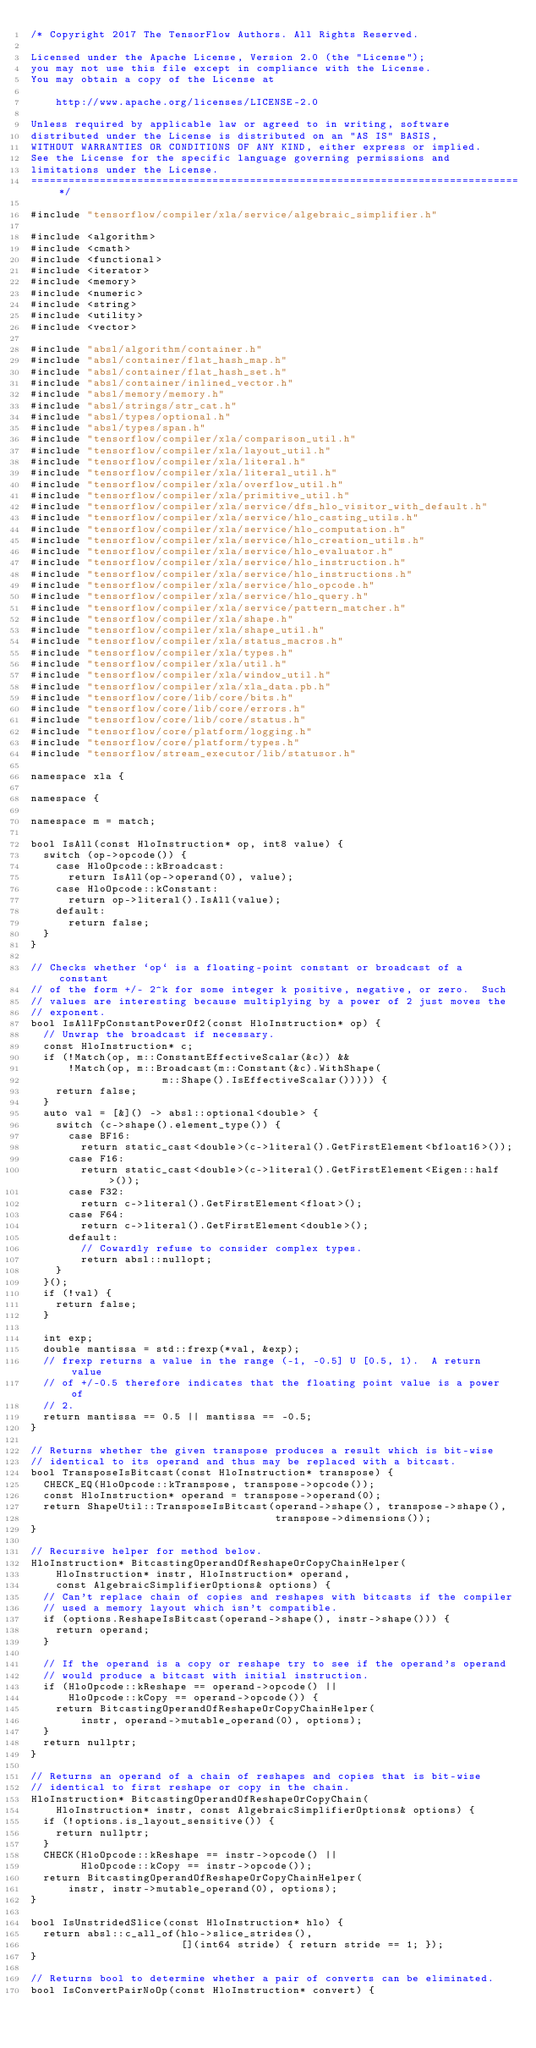Convert code to text. <code><loc_0><loc_0><loc_500><loc_500><_C++_>/* Copyright 2017 The TensorFlow Authors. All Rights Reserved.

Licensed under the Apache License, Version 2.0 (the "License");
you may not use this file except in compliance with the License.
You may obtain a copy of the License at

    http://www.apache.org/licenses/LICENSE-2.0

Unless required by applicable law or agreed to in writing, software
distributed under the License is distributed on an "AS IS" BASIS,
WITHOUT WARRANTIES OR CONDITIONS OF ANY KIND, either express or implied.
See the License for the specific language governing permissions and
limitations under the License.
==============================================================================*/

#include "tensorflow/compiler/xla/service/algebraic_simplifier.h"

#include <algorithm>
#include <cmath>
#include <functional>
#include <iterator>
#include <memory>
#include <numeric>
#include <string>
#include <utility>
#include <vector>

#include "absl/algorithm/container.h"
#include "absl/container/flat_hash_map.h"
#include "absl/container/flat_hash_set.h"
#include "absl/container/inlined_vector.h"
#include "absl/memory/memory.h"
#include "absl/strings/str_cat.h"
#include "absl/types/optional.h"
#include "absl/types/span.h"
#include "tensorflow/compiler/xla/comparison_util.h"
#include "tensorflow/compiler/xla/layout_util.h"
#include "tensorflow/compiler/xla/literal.h"
#include "tensorflow/compiler/xla/literal_util.h"
#include "tensorflow/compiler/xla/overflow_util.h"
#include "tensorflow/compiler/xla/primitive_util.h"
#include "tensorflow/compiler/xla/service/dfs_hlo_visitor_with_default.h"
#include "tensorflow/compiler/xla/service/hlo_casting_utils.h"
#include "tensorflow/compiler/xla/service/hlo_computation.h"
#include "tensorflow/compiler/xla/service/hlo_creation_utils.h"
#include "tensorflow/compiler/xla/service/hlo_evaluator.h"
#include "tensorflow/compiler/xla/service/hlo_instruction.h"
#include "tensorflow/compiler/xla/service/hlo_instructions.h"
#include "tensorflow/compiler/xla/service/hlo_opcode.h"
#include "tensorflow/compiler/xla/service/hlo_query.h"
#include "tensorflow/compiler/xla/service/pattern_matcher.h"
#include "tensorflow/compiler/xla/shape.h"
#include "tensorflow/compiler/xla/shape_util.h"
#include "tensorflow/compiler/xla/status_macros.h"
#include "tensorflow/compiler/xla/types.h"
#include "tensorflow/compiler/xla/util.h"
#include "tensorflow/compiler/xla/window_util.h"
#include "tensorflow/compiler/xla/xla_data.pb.h"
#include "tensorflow/core/lib/core/bits.h"
#include "tensorflow/core/lib/core/errors.h"
#include "tensorflow/core/lib/core/status.h"
#include "tensorflow/core/platform/logging.h"
#include "tensorflow/core/platform/types.h"
#include "tensorflow/stream_executor/lib/statusor.h"

namespace xla {

namespace {

namespace m = match;

bool IsAll(const HloInstruction* op, int8 value) {
  switch (op->opcode()) {
    case HloOpcode::kBroadcast:
      return IsAll(op->operand(0), value);
    case HloOpcode::kConstant:
      return op->literal().IsAll(value);
    default:
      return false;
  }
}

// Checks whether `op` is a floating-point constant or broadcast of a constant
// of the form +/- 2^k for some integer k positive, negative, or zero.  Such
// values are interesting because multiplying by a power of 2 just moves the
// exponent.
bool IsAllFpConstantPowerOf2(const HloInstruction* op) {
  // Unwrap the broadcast if necessary.
  const HloInstruction* c;
  if (!Match(op, m::ConstantEffectiveScalar(&c)) &&
      !Match(op, m::Broadcast(m::Constant(&c).WithShape(
                     m::Shape().IsEffectiveScalar())))) {
    return false;
  }
  auto val = [&]() -> absl::optional<double> {
    switch (c->shape().element_type()) {
      case BF16:
        return static_cast<double>(c->literal().GetFirstElement<bfloat16>());
      case F16:
        return static_cast<double>(c->literal().GetFirstElement<Eigen::half>());
      case F32:
        return c->literal().GetFirstElement<float>();
      case F64:
        return c->literal().GetFirstElement<double>();
      default:
        // Cowardly refuse to consider complex types.
        return absl::nullopt;
    }
  }();
  if (!val) {
    return false;
  }

  int exp;
  double mantissa = std::frexp(*val, &exp);
  // frexp returns a value in the range (-1, -0.5] U [0.5, 1).  A return value
  // of +/-0.5 therefore indicates that the floating point value is a power of
  // 2.
  return mantissa == 0.5 || mantissa == -0.5;
}

// Returns whether the given transpose produces a result which is bit-wise
// identical to its operand and thus may be replaced with a bitcast.
bool TransposeIsBitcast(const HloInstruction* transpose) {
  CHECK_EQ(HloOpcode::kTranspose, transpose->opcode());
  const HloInstruction* operand = transpose->operand(0);
  return ShapeUtil::TransposeIsBitcast(operand->shape(), transpose->shape(),
                                       transpose->dimensions());
}

// Recursive helper for method below.
HloInstruction* BitcastingOperandOfReshapeOrCopyChainHelper(
    HloInstruction* instr, HloInstruction* operand,
    const AlgebraicSimplifierOptions& options) {
  // Can't replace chain of copies and reshapes with bitcasts if the compiler
  // used a memory layout which isn't compatible.
  if (options.ReshapeIsBitcast(operand->shape(), instr->shape())) {
    return operand;
  }

  // If the operand is a copy or reshape try to see if the operand's operand
  // would produce a bitcast with initial instruction.
  if (HloOpcode::kReshape == operand->opcode() ||
      HloOpcode::kCopy == operand->opcode()) {
    return BitcastingOperandOfReshapeOrCopyChainHelper(
        instr, operand->mutable_operand(0), options);
  }
  return nullptr;
}

// Returns an operand of a chain of reshapes and copies that is bit-wise
// identical to first reshape or copy in the chain.
HloInstruction* BitcastingOperandOfReshapeOrCopyChain(
    HloInstruction* instr, const AlgebraicSimplifierOptions& options) {
  if (!options.is_layout_sensitive()) {
    return nullptr;
  }
  CHECK(HloOpcode::kReshape == instr->opcode() ||
        HloOpcode::kCopy == instr->opcode());
  return BitcastingOperandOfReshapeOrCopyChainHelper(
      instr, instr->mutable_operand(0), options);
}

bool IsUnstridedSlice(const HloInstruction* hlo) {
  return absl::c_all_of(hlo->slice_strides(),
                        [](int64 stride) { return stride == 1; });
}

// Returns bool to determine whether a pair of converts can be eliminated.
bool IsConvertPairNoOp(const HloInstruction* convert) {</code> 